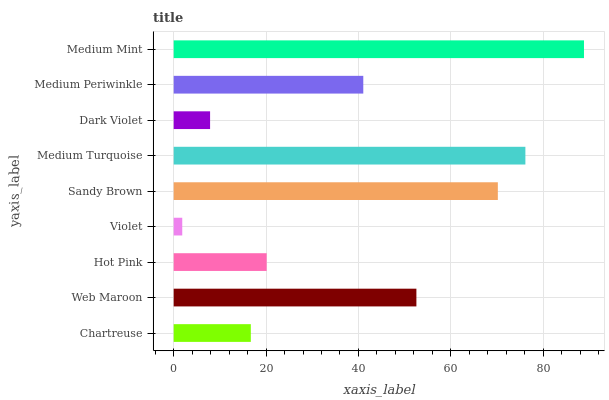Is Violet the minimum?
Answer yes or no. Yes. Is Medium Mint the maximum?
Answer yes or no. Yes. Is Web Maroon the minimum?
Answer yes or no. No. Is Web Maroon the maximum?
Answer yes or no. No. Is Web Maroon greater than Chartreuse?
Answer yes or no. Yes. Is Chartreuse less than Web Maroon?
Answer yes or no. Yes. Is Chartreuse greater than Web Maroon?
Answer yes or no. No. Is Web Maroon less than Chartreuse?
Answer yes or no. No. Is Medium Periwinkle the high median?
Answer yes or no. Yes. Is Medium Periwinkle the low median?
Answer yes or no. Yes. Is Violet the high median?
Answer yes or no. No. Is Violet the low median?
Answer yes or no. No. 